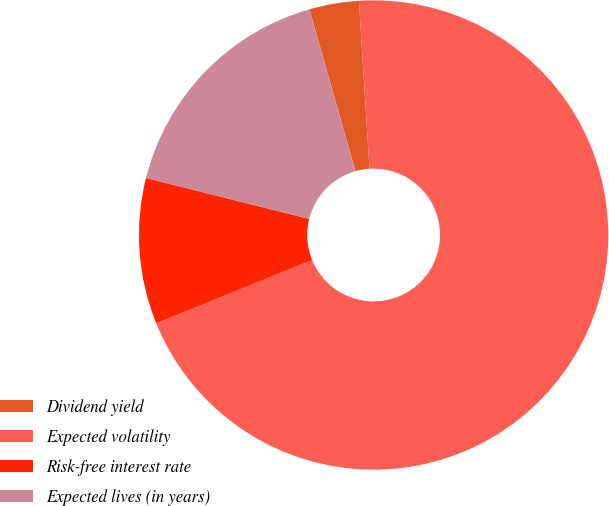<chart> <loc_0><loc_0><loc_500><loc_500><pie_chart><fcel>Dividend yield<fcel>Expected volatility<fcel>Risk-free interest rate<fcel>Expected lives (in years)<nl><fcel>3.41%<fcel>69.85%<fcel>10.05%<fcel>16.68%<nl></chart> 